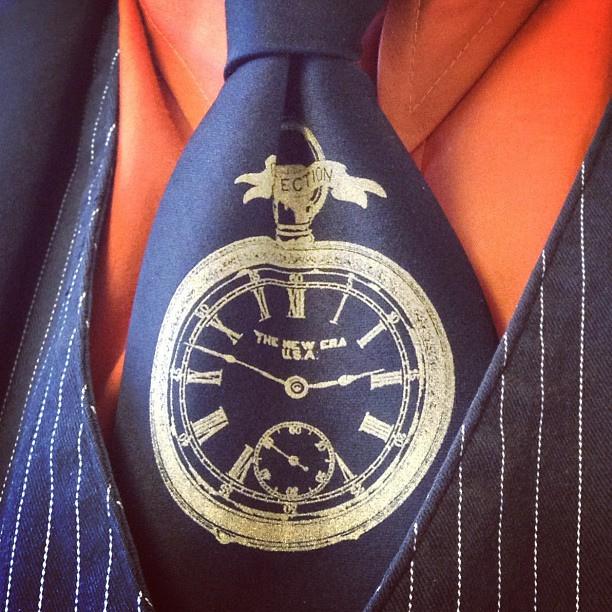What sign is on the tie?
Write a very short answer. Clock. What time does the clock say?
Concise answer only. 2:47. What gender is the person being photographed?
Answer briefly. Male. 